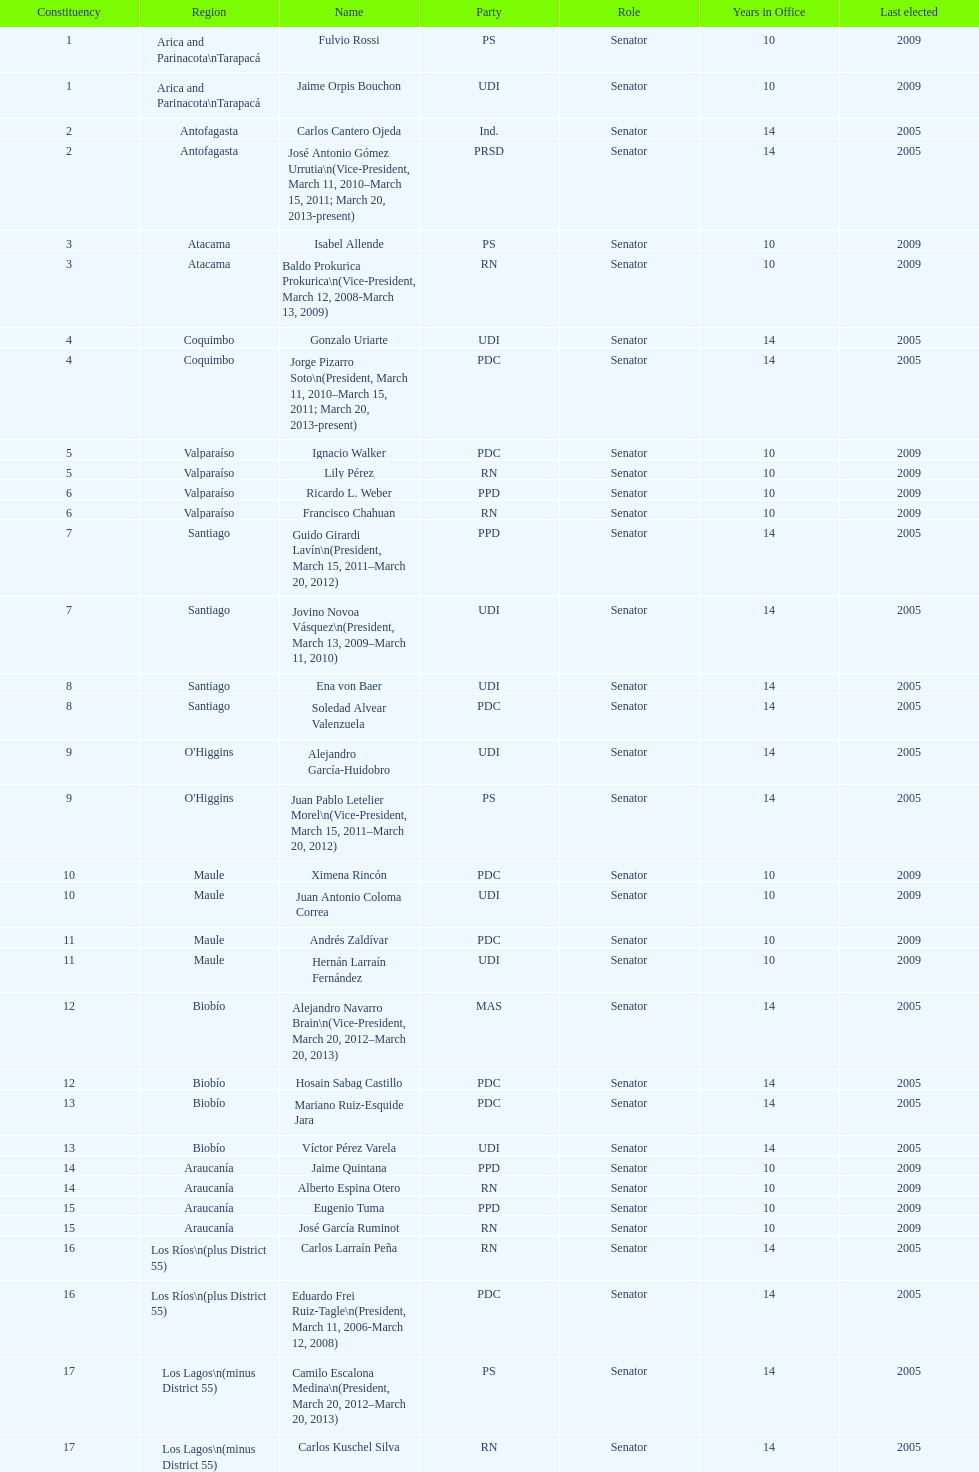How long was baldo prokurica prokurica vice-president? 1 year. 